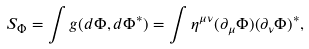<formula> <loc_0><loc_0><loc_500><loc_500>S _ { \Phi } = \int g ( d \Phi , d \Phi ^ { * } ) = \int \eta ^ { \mu \nu } ( \partial _ { \mu } \Phi ) ( \partial _ { \nu } \Phi ) ^ { * } ,</formula> 